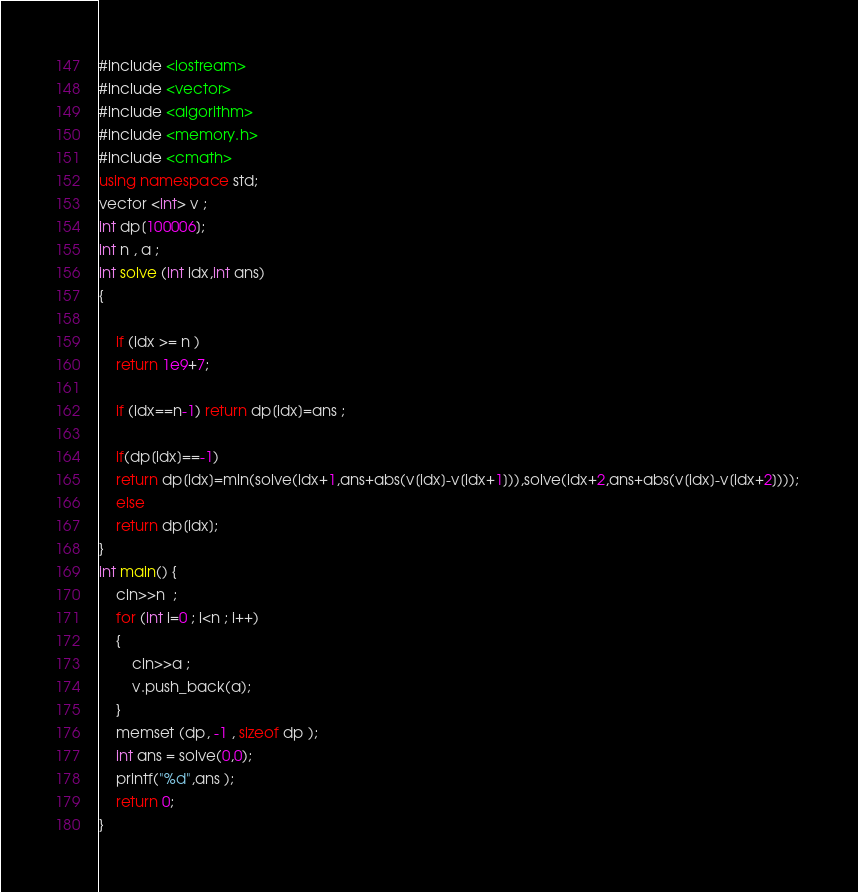<code> <loc_0><loc_0><loc_500><loc_500><_C++_>#include <iostream>
#include <vector>
#include <algorithm>
#include <memory.h>
#include <cmath>
using namespace std;
vector <int> v ;
int dp[100006]; 
int n , a ; 
int solve (int idx,int ans)
{
	
	if (idx >= n )
	return 1e9+7; 
	
	if (idx==n-1) return dp[idx]=ans ; 
	
	if(dp[idx]==-1)
	return dp[idx]=min(solve(idx+1,ans+abs(v[idx]-v[idx+1])),solve(idx+2,ans+abs(v[idx]-v[idx+2]))); 
	else
	return dp[idx]; 
}
int main() {
	cin>>n  ; 
	for (int i=0 ; i<n ; i++)
	{
		cin>>a ; 
		v.push_back(a);
	}
	memset (dp, -1 , sizeof dp ); 
	int ans = solve(0,0); 
	printf("%d",ans ); 
	return 0;
}</code> 